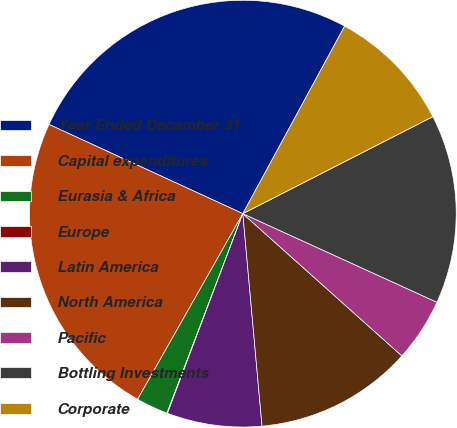Convert chart. <chart><loc_0><loc_0><loc_500><loc_500><pie_chart><fcel>Year Ended December 31<fcel>Capital expenditures<fcel>Eurasia & Africa<fcel>Europe<fcel>Latin America<fcel>North America<fcel>Pacific<fcel>Bottling Investments<fcel>Corporate<nl><fcel>26.05%<fcel>23.66%<fcel>2.42%<fcel>0.04%<fcel>7.18%<fcel>11.95%<fcel>4.8%<fcel>14.33%<fcel>9.57%<nl></chart> 